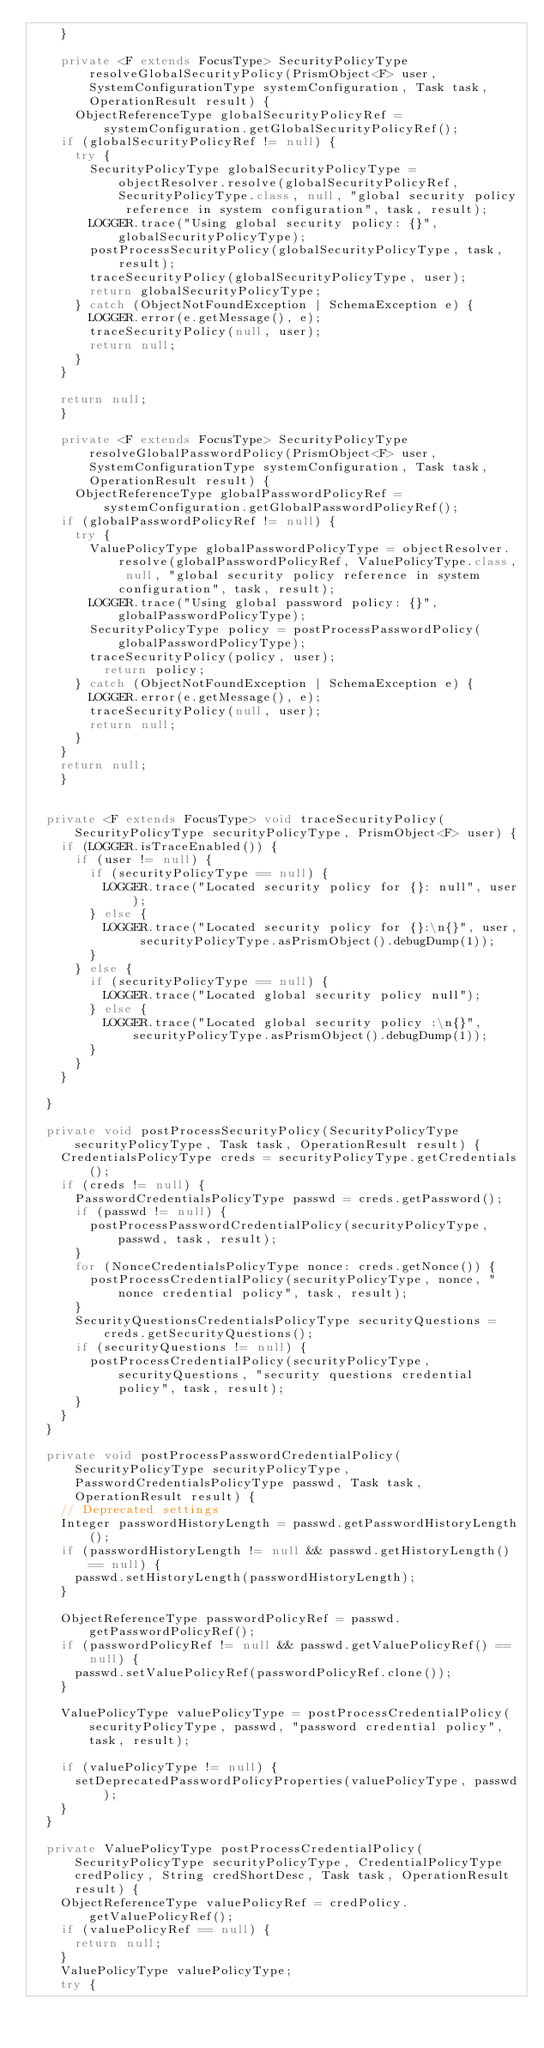Convert code to text. <code><loc_0><loc_0><loc_500><loc_500><_Java_>    }

    private <F extends FocusType> SecurityPolicyType resolveGlobalSecurityPolicy(PrismObject<F> user, SystemConfigurationType systemConfiguration, Task task, OperationResult result) {
    	ObjectReferenceType globalSecurityPolicyRef = systemConfiguration.getGlobalSecurityPolicyRef();
		if (globalSecurityPolicyRef != null) {
			try {
				SecurityPolicyType globalSecurityPolicyType = objectResolver.resolve(globalSecurityPolicyRef, SecurityPolicyType.class, null, "global security policy reference in system configuration", task, result);
				LOGGER.trace("Using global security policy: {}", globalSecurityPolicyType);
				postProcessSecurityPolicy(globalSecurityPolicyType, task, result);
				traceSecurityPolicy(globalSecurityPolicyType, user);
				return globalSecurityPolicyType;
			} catch (ObjectNotFoundException | SchemaException e) {
				LOGGER.error(e.getMessage(), e);
				traceSecurityPolicy(null, user);
				return null;
			}
		}

		return null;
    }

    private <F extends FocusType> SecurityPolicyType resolveGlobalPasswordPolicy(PrismObject<F> user, SystemConfigurationType systemConfiguration, Task task, OperationResult result) {
    	ObjectReferenceType globalPasswordPolicyRef = systemConfiguration.getGlobalPasswordPolicyRef();
		if (globalPasswordPolicyRef != null) {
			try {
				ValuePolicyType globalPasswordPolicyType = objectResolver.resolve(globalPasswordPolicyRef, ValuePolicyType.class, null, "global security policy reference in system configuration", task, result);
				LOGGER.trace("Using global password policy: {}", globalPasswordPolicyType);
				SecurityPolicyType policy = postProcessPasswordPolicy(globalPasswordPolicyType);
				traceSecurityPolicy(policy, user);
	    		return policy;
			} catch (ObjectNotFoundException | SchemaException e) {
				LOGGER.error(e.getMessage(), e);
				traceSecurityPolicy(null, user);
				return null;
			}
		}
		return null;
    }


	private <F extends FocusType> void traceSecurityPolicy(SecurityPolicyType securityPolicyType, PrismObject<F> user) {
		if (LOGGER.isTraceEnabled()) {
			if (user != null) {
				if (securityPolicyType == null) {
					LOGGER.trace("Located security policy for {}: null", user);
				} else {
					LOGGER.trace("Located security policy for {}:\n{}", user, securityPolicyType.asPrismObject().debugDump(1));
				}
			} else {
				if (securityPolicyType == null) {
					LOGGER.trace("Located global security policy null");
				} else {
					LOGGER.trace("Located global security policy :\n{}", securityPolicyType.asPrismObject().debugDump(1));
				}
			}
		}

	}

	private void postProcessSecurityPolicy(SecurityPolicyType securityPolicyType, Task task, OperationResult result) {
		CredentialsPolicyType creds = securityPolicyType.getCredentials();
		if (creds != null) {
			PasswordCredentialsPolicyType passwd = creds.getPassword();
			if (passwd != null) {
				postProcessPasswordCredentialPolicy(securityPolicyType, passwd, task, result);
			}
			for (NonceCredentialsPolicyType nonce: creds.getNonce()) {
				postProcessCredentialPolicy(securityPolicyType, nonce, "nonce credential policy", task, result);
			}
			SecurityQuestionsCredentialsPolicyType securityQuestions = creds.getSecurityQuestions();
			if (securityQuestions != null) {
				postProcessCredentialPolicy(securityPolicyType, securityQuestions, "security questions credential policy", task, result);
			}
		}
	}

	private void postProcessPasswordCredentialPolicy(SecurityPolicyType securityPolicyType, PasswordCredentialsPolicyType passwd, Task task, OperationResult result) {
		// Deprecated settings
		Integer passwordHistoryLength = passwd.getPasswordHistoryLength();
		if (passwordHistoryLength != null && passwd.getHistoryLength() == null) {
			passwd.setHistoryLength(passwordHistoryLength);
		}

		ObjectReferenceType passwordPolicyRef = passwd.getPasswordPolicyRef();
		if (passwordPolicyRef != null && passwd.getValuePolicyRef() == null) {
			passwd.setValuePolicyRef(passwordPolicyRef.clone());
		}

		ValuePolicyType valuePolicyType = postProcessCredentialPolicy(securityPolicyType, passwd, "password credential policy", task, result);

		if (valuePolicyType != null) {
			setDeprecatedPasswordPolicyProperties(valuePolicyType, passwd);
		}
	}

	private ValuePolicyType postProcessCredentialPolicy(SecurityPolicyType securityPolicyType, CredentialPolicyType credPolicy, String credShortDesc, Task task, OperationResult result) {
		ObjectReferenceType valuePolicyRef = credPolicy.getValuePolicyRef();
		if (valuePolicyRef == null) {
			return null;
		}
		ValuePolicyType valuePolicyType;
		try {</code> 